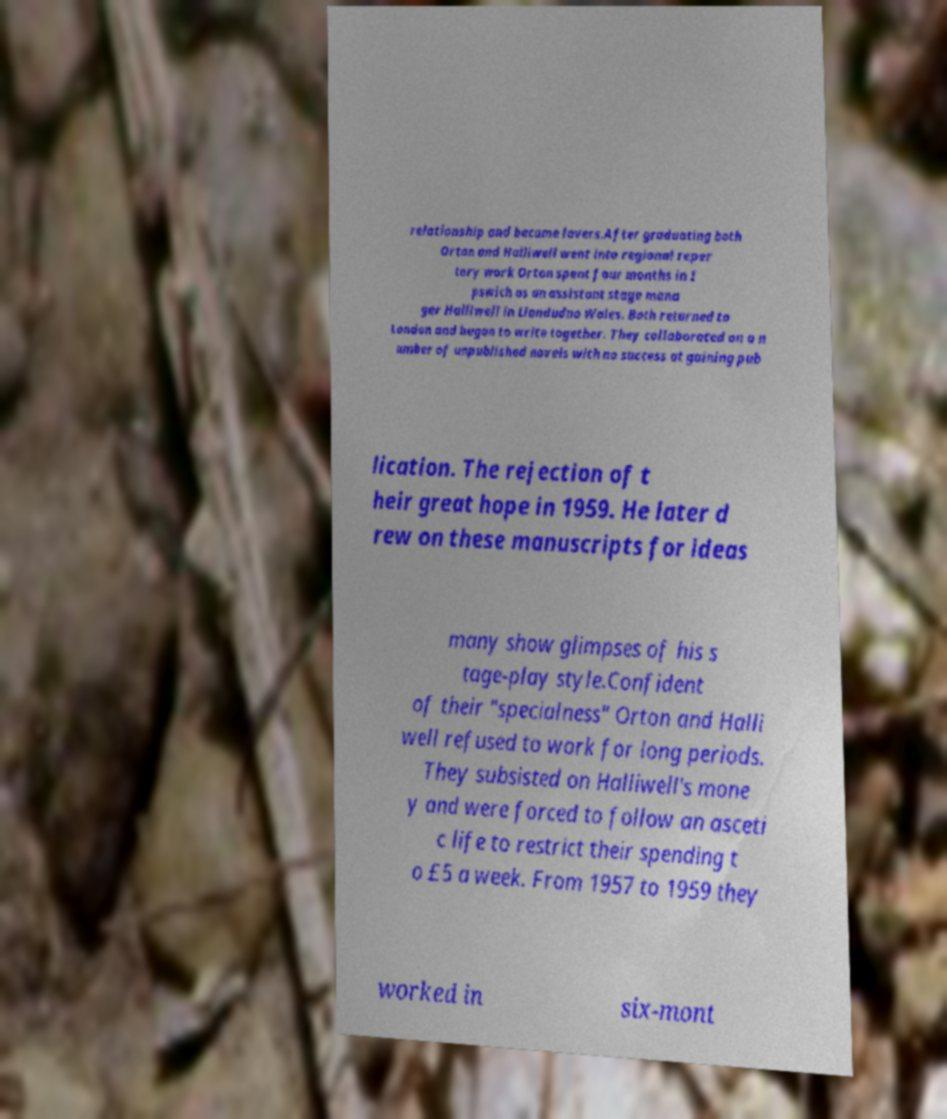For documentation purposes, I need the text within this image transcribed. Could you provide that? relationship and became lovers.After graduating both Orton and Halliwell went into regional reper tory work Orton spent four months in I pswich as an assistant stage mana ger Halliwell in Llandudno Wales. Both returned to London and began to write together. They collaborated on a n umber of unpublished novels with no success at gaining pub lication. The rejection of t heir great hope in 1959. He later d rew on these manuscripts for ideas many show glimpses of his s tage-play style.Confident of their "specialness" Orton and Halli well refused to work for long periods. They subsisted on Halliwell's mone y and were forced to follow an asceti c life to restrict their spending t o £5 a week. From 1957 to 1959 they worked in six-mont 